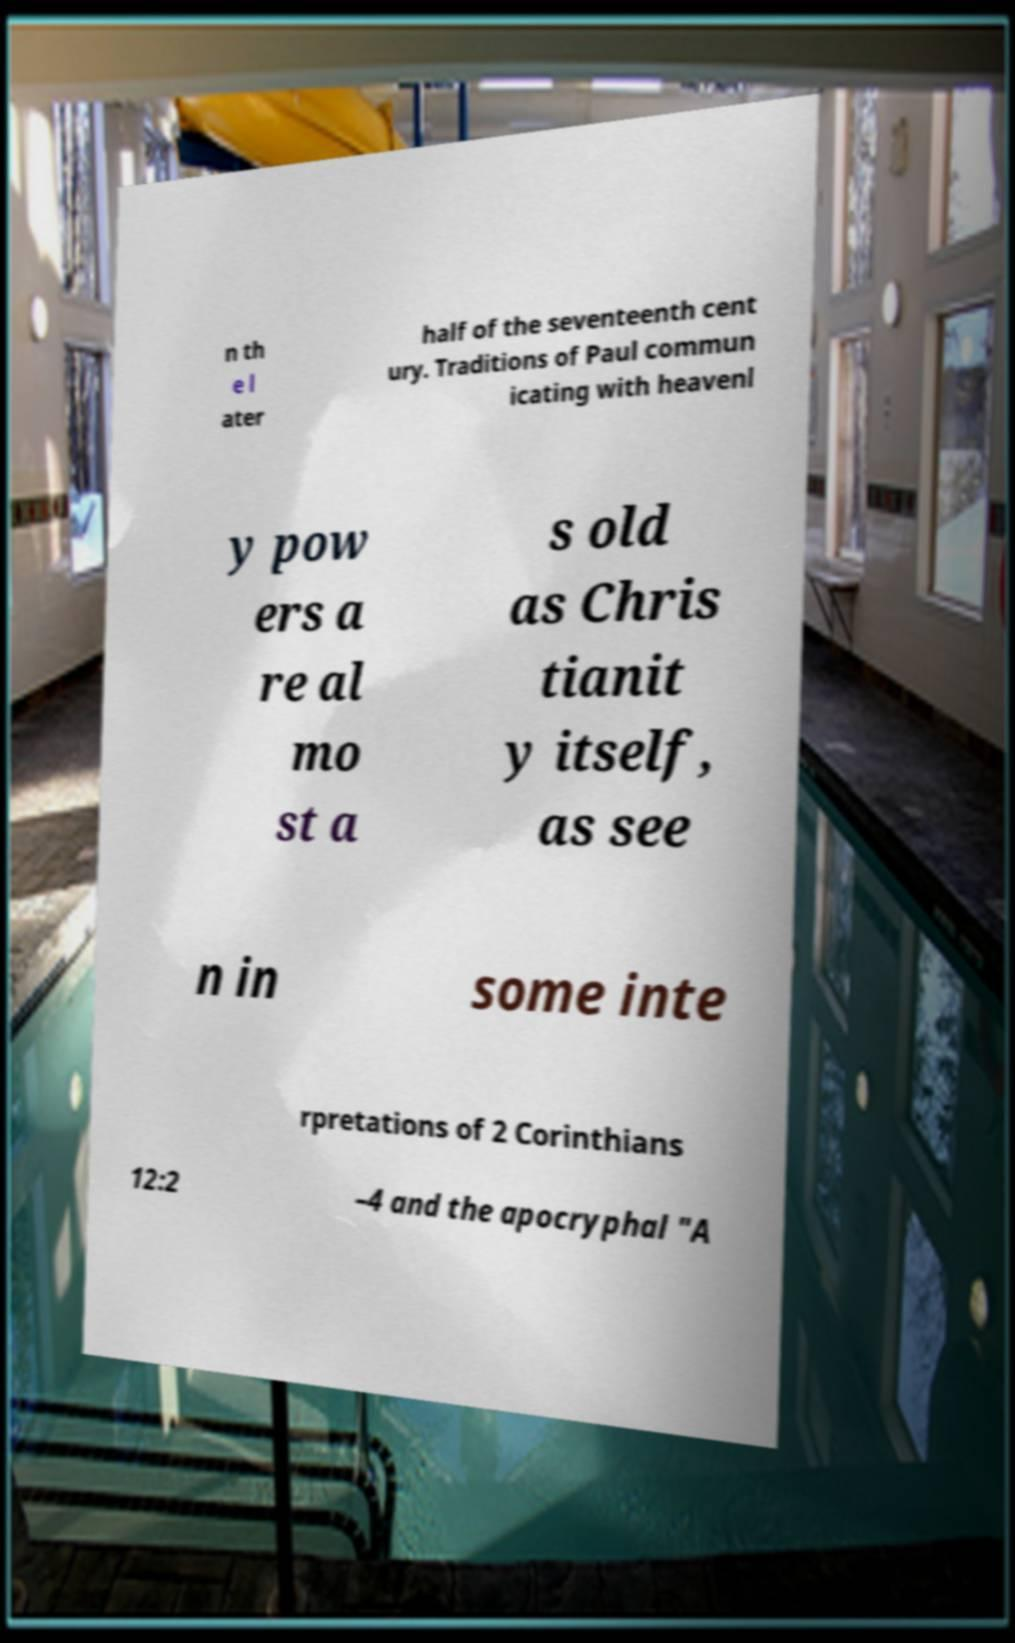What messages or text are displayed in this image? I need them in a readable, typed format. n th e l ater half of the seventeenth cent ury. Traditions of Paul commun icating with heavenl y pow ers a re al mo st a s old as Chris tianit y itself, as see n in some inte rpretations of 2 Corinthians 12:2 –4 and the apocryphal "A 